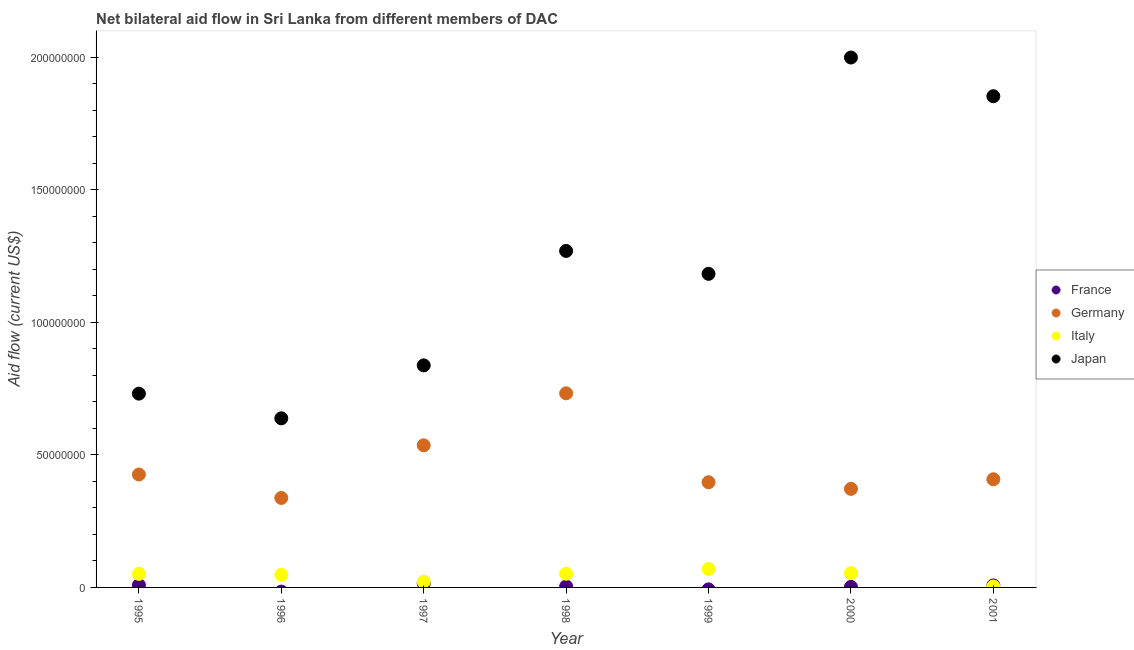Is the number of dotlines equal to the number of legend labels?
Give a very brief answer. No. What is the amount of aid given by germany in 2000?
Your answer should be compact. 3.72e+07. Across all years, what is the maximum amount of aid given by japan?
Offer a terse response. 2.00e+08. Across all years, what is the minimum amount of aid given by italy?
Keep it short and to the point. 3.50e+05. What is the total amount of aid given by japan in the graph?
Your answer should be very brief. 8.51e+08. What is the difference between the amount of aid given by italy in 1995 and that in 2000?
Ensure brevity in your answer.  -3.20e+05. What is the difference between the amount of aid given by italy in 1997 and the amount of aid given by japan in 1998?
Provide a short and direct response. -1.25e+08. What is the average amount of aid given by france per year?
Make the answer very short. 5.44e+05. In the year 2001, what is the difference between the amount of aid given by italy and amount of aid given by japan?
Your answer should be very brief. -1.85e+08. Is the difference between the amount of aid given by france in 1998 and 2001 greater than the difference between the amount of aid given by germany in 1998 and 2001?
Offer a terse response. No. What is the difference between the highest and the second highest amount of aid given by italy?
Your answer should be compact. 1.51e+06. What is the difference between the highest and the lowest amount of aid given by japan?
Give a very brief answer. 1.36e+08. Is the sum of the amount of aid given by germany in 1996 and 2000 greater than the maximum amount of aid given by italy across all years?
Your answer should be compact. Yes. Is it the case that in every year, the sum of the amount of aid given by italy and amount of aid given by japan is greater than the sum of amount of aid given by france and amount of aid given by germany?
Provide a short and direct response. No. How many dotlines are there?
Offer a very short reply. 4. How many years are there in the graph?
Your response must be concise. 7. Does the graph contain any zero values?
Offer a very short reply. Yes. Does the graph contain grids?
Keep it short and to the point. No. How are the legend labels stacked?
Your answer should be compact. Vertical. What is the title of the graph?
Ensure brevity in your answer.  Net bilateral aid flow in Sri Lanka from different members of DAC. What is the label or title of the X-axis?
Your answer should be compact. Year. What is the Aid flow (current US$) of France in 1995?
Keep it short and to the point. 9.00e+05. What is the Aid flow (current US$) in Germany in 1995?
Provide a short and direct response. 4.26e+07. What is the Aid flow (current US$) of Italy in 1995?
Keep it short and to the point. 5.10e+06. What is the Aid flow (current US$) of Japan in 1995?
Provide a short and direct response. 7.31e+07. What is the Aid flow (current US$) of Germany in 1996?
Your answer should be very brief. 3.37e+07. What is the Aid flow (current US$) of Italy in 1996?
Make the answer very short. 4.78e+06. What is the Aid flow (current US$) in Japan in 1996?
Offer a very short reply. 6.38e+07. What is the Aid flow (current US$) in France in 1997?
Offer a terse response. 1.56e+06. What is the Aid flow (current US$) in Germany in 1997?
Make the answer very short. 5.36e+07. What is the Aid flow (current US$) of Italy in 1997?
Keep it short and to the point. 2.17e+06. What is the Aid flow (current US$) of Japan in 1997?
Give a very brief answer. 8.37e+07. What is the Aid flow (current US$) of Germany in 1998?
Your response must be concise. 7.32e+07. What is the Aid flow (current US$) of Italy in 1998?
Your response must be concise. 5.15e+06. What is the Aid flow (current US$) in Japan in 1998?
Offer a terse response. 1.27e+08. What is the Aid flow (current US$) of Germany in 1999?
Keep it short and to the point. 3.97e+07. What is the Aid flow (current US$) of Italy in 1999?
Ensure brevity in your answer.  6.93e+06. What is the Aid flow (current US$) of Japan in 1999?
Keep it short and to the point. 1.18e+08. What is the Aid flow (current US$) in Germany in 2000?
Give a very brief answer. 3.72e+07. What is the Aid flow (current US$) in Italy in 2000?
Keep it short and to the point. 5.42e+06. What is the Aid flow (current US$) in Japan in 2000?
Your answer should be compact. 2.00e+08. What is the Aid flow (current US$) in France in 2001?
Provide a short and direct response. 7.60e+05. What is the Aid flow (current US$) in Germany in 2001?
Ensure brevity in your answer.  4.08e+07. What is the Aid flow (current US$) of Japan in 2001?
Your answer should be very brief. 1.85e+08. Across all years, what is the maximum Aid flow (current US$) in France?
Offer a very short reply. 1.56e+06. Across all years, what is the maximum Aid flow (current US$) in Germany?
Your answer should be compact. 7.32e+07. Across all years, what is the maximum Aid flow (current US$) of Italy?
Your answer should be very brief. 6.93e+06. Across all years, what is the maximum Aid flow (current US$) in Japan?
Offer a very short reply. 2.00e+08. Across all years, what is the minimum Aid flow (current US$) in Germany?
Offer a very short reply. 3.37e+07. Across all years, what is the minimum Aid flow (current US$) of Italy?
Make the answer very short. 3.50e+05. Across all years, what is the minimum Aid flow (current US$) of Japan?
Give a very brief answer. 6.38e+07. What is the total Aid flow (current US$) in France in the graph?
Your answer should be very brief. 3.81e+06. What is the total Aid flow (current US$) in Germany in the graph?
Your response must be concise. 3.21e+08. What is the total Aid flow (current US$) in Italy in the graph?
Offer a very short reply. 2.99e+07. What is the total Aid flow (current US$) in Japan in the graph?
Give a very brief answer. 8.51e+08. What is the difference between the Aid flow (current US$) in Germany in 1995 and that in 1996?
Keep it short and to the point. 8.84e+06. What is the difference between the Aid flow (current US$) in Japan in 1995 and that in 1996?
Ensure brevity in your answer.  9.31e+06. What is the difference between the Aid flow (current US$) in France in 1995 and that in 1997?
Provide a short and direct response. -6.60e+05. What is the difference between the Aid flow (current US$) in Germany in 1995 and that in 1997?
Provide a short and direct response. -1.10e+07. What is the difference between the Aid flow (current US$) of Italy in 1995 and that in 1997?
Your answer should be very brief. 2.93e+06. What is the difference between the Aid flow (current US$) of Japan in 1995 and that in 1997?
Your answer should be very brief. -1.07e+07. What is the difference between the Aid flow (current US$) in France in 1995 and that in 1998?
Make the answer very short. 5.10e+05. What is the difference between the Aid flow (current US$) of Germany in 1995 and that in 1998?
Keep it short and to the point. -3.06e+07. What is the difference between the Aid flow (current US$) in Italy in 1995 and that in 1998?
Offer a very short reply. -5.00e+04. What is the difference between the Aid flow (current US$) of Japan in 1995 and that in 1998?
Your response must be concise. -5.38e+07. What is the difference between the Aid flow (current US$) of Germany in 1995 and that in 1999?
Provide a succinct answer. 2.91e+06. What is the difference between the Aid flow (current US$) of Italy in 1995 and that in 1999?
Your answer should be compact. -1.83e+06. What is the difference between the Aid flow (current US$) of Japan in 1995 and that in 1999?
Offer a very short reply. -4.52e+07. What is the difference between the Aid flow (current US$) in Germany in 1995 and that in 2000?
Your answer should be very brief. 5.41e+06. What is the difference between the Aid flow (current US$) of Italy in 1995 and that in 2000?
Provide a short and direct response. -3.20e+05. What is the difference between the Aid flow (current US$) of Japan in 1995 and that in 2000?
Ensure brevity in your answer.  -1.27e+08. What is the difference between the Aid flow (current US$) in Germany in 1995 and that in 2001?
Keep it short and to the point. 1.79e+06. What is the difference between the Aid flow (current US$) in Italy in 1995 and that in 2001?
Keep it short and to the point. 4.75e+06. What is the difference between the Aid flow (current US$) of Japan in 1995 and that in 2001?
Make the answer very short. -1.12e+08. What is the difference between the Aid flow (current US$) in Germany in 1996 and that in 1997?
Your answer should be compact. -1.98e+07. What is the difference between the Aid flow (current US$) in Italy in 1996 and that in 1997?
Your answer should be very brief. 2.61e+06. What is the difference between the Aid flow (current US$) in Japan in 1996 and that in 1997?
Your answer should be compact. -2.00e+07. What is the difference between the Aid flow (current US$) of Germany in 1996 and that in 1998?
Your answer should be very brief. -3.95e+07. What is the difference between the Aid flow (current US$) in Italy in 1996 and that in 1998?
Keep it short and to the point. -3.70e+05. What is the difference between the Aid flow (current US$) in Japan in 1996 and that in 1998?
Offer a very short reply. -6.31e+07. What is the difference between the Aid flow (current US$) of Germany in 1996 and that in 1999?
Provide a succinct answer. -5.93e+06. What is the difference between the Aid flow (current US$) of Italy in 1996 and that in 1999?
Offer a terse response. -2.15e+06. What is the difference between the Aid flow (current US$) of Japan in 1996 and that in 1999?
Offer a very short reply. -5.45e+07. What is the difference between the Aid flow (current US$) in Germany in 1996 and that in 2000?
Your answer should be compact. -3.43e+06. What is the difference between the Aid flow (current US$) of Italy in 1996 and that in 2000?
Offer a very short reply. -6.40e+05. What is the difference between the Aid flow (current US$) of Japan in 1996 and that in 2000?
Provide a succinct answer. -1.36e+08. What is the difference between the Aid flow (current US$) of Germany in 1996 and that in 2001?
Your answer should be very brief. -7.05e+06. What is the difference between the Aid flow (current US$) of Italy in 1996 and that in 2001?
Keep it short and to the point. 4.43e+06. What is the difference between the Aid flow (current US$) in Japan in 1996 and that in 2001?
Offer a terse response. -1.21e+08. What is the difference between the Aid flow (current US$) of France in 1997 and that in 1998?
Offer a very short reply. 1.17e+06. What is the difference between the Aid flow (current US$) of Germany in 1997 and that in 1998?
Ensure brevity in your answer.  -1.96e+07. What is the difference between the Aid flow (current US$) in Italy in 1997 and that in 1998?
Provide a succinct answer. -2.98e+06. What is the difference between the Aid flow (current US$) in Japan in 1997 and that in 1998?
Your answer should be very brief. -4.32e+07. What is the difference between the Aid flow (current US$) of Germany in 1997 and that in 1999?
Offer a terse response. 1.39e+07. What is the difference between the Aid flow (current US$) in Italy in 1997 and that in 1999?
Your answer should be compact. -4.76e+06. What is the difference between the Aid flow (current US$) of Japan in 1997 and that in 1999?
Give a very brief answer. -3.45e+07. What is the difference between the Aid flow (current US$) of France in 1997 and that in 2000?
Offer a terse response. 1.36e+06. What is the difference between the Aid flow (current US$) of Germany in 1997 and that in 2000?
Your response must be concise. 1.64e+07. What is the difference between the Aid flow (current US$) in Italy in 1997 and that in 2000?
Provide a short and direct response. -3.25e+06. What is the difference between the Aid flow (current US$) of Japan in 1997 and that in 2000?
Your response must be concise. -1.16e+08. What is the difference between the Aid flow (current US$) of France in 1997 and that in 2001?
Provide a succinct answer. 8.00e+05. What is the difference between the Aid flow (current US$) in Germany in 1997 and that in 2001?
Your response must be concise. 1.28e+07. What is the difference between the Aid flow (current US$) of Italy in 1997 and that in 2001?
Keep it short and to the point. 1.82e+06. What is the difference between the Aid flow (current US$) in Japan in 1997 and that in 2001?
Offer a terse response. -1.02e+08. What is the difference between the Aid flow (current US$) in Germany in 1998 and that in 1999?
Provide a short and direct response. 3.35e+07. What is the difference between the Aid flow (current US$) in Italy in 1998 and that in 1999?
Your answer should be compact. -1.78e+06. What is the difference between the Aid flow (current US$) in Japan in 1998 and that in 1999?
Offer a very short reply. 8.65e+06. What is the difference between the Aid flow (current US$) of France in 1998 and that in 2000?
Keep it short and to the point. 1.90e+05. What is the difference between the Aid flow (current US$) of Germany in 1998 and that in 2000?
Ensure brevity in your answer.  3.60e+07. What is the difference between the Aid flow (current US$) of Japan in 1998 and that in 2000?
Your response must be concise. -7.29e+07. What is the difference between the Aid flow (current US$) of France in 1998 and that in 2001?
Offer a very short reply. -3.70e+05. What is the difference between the Aid flow (current US$) of Germany in 1998 and that in 2001?
Your response must be concise. 3.24e+07. What is the difference between the Aid flow (current US$) in Italy in 1998 and that in 2001?
Provide a short and direct response. 4.80e+06. What is the difference between the Aid flow (current US$) in Japan in 1998 and that in 2001?
Your answer should be compact. -5.83e+07. What is the difference between the Aid flow (current US$) in Germany in 1999 and that in 2000?
Your answer should be compact. 2.50e+06. What is the difference between the Aid flow (current US$) in Italy in 1999 and that in 2000?
Your answer should be very brief. 1.51e+06. What is the difference between the Aid flow (current US$) in Japan in 1999 and that in 2000?
Offer a terse response. -8.16e+07. What is the difference between the Aid flow (current US$) of Germany in 1999 and that in 2001?
Your answer should be very brief. -1.12e+06. What is the difference between the Aid flow (current US$) of Italy in 1999 and that in 2001?
Your answer should be very brief. 6.58e+06. What is the difference between the Aid flow (current US$) of Japan in 1999 and that in 2001?
Ensure brevity in your answer.  -6.70e+07. What is the difference between the Aid flow (current US$) in France in 2000 and that in 2001?
Your answer should be very brief. -5.60e+05. What is the difference between the Aid flow (current US$) of Germany in 2000 and that in 2001?
Your answer should be very brief. -3.62e+06. What is the difference between the Aid flow (current US$) in Italy in 2000 and that in 2001?
Keep it short and to the point. 5.07e+06. What is the difference between the Aid flow (current US$) of Japan in 2000 and that in 2001?
Your answer should be very brief. 1.46e+07. What is the difference between the Aid flow (current US$) of France in 1995 and the Aid flow (current US$) of Germany in 1996?
Give a very brief answer. -3.28e+07. What is the difference between the Aid flow (current US$) of France in 1995 and the Aid flow (current US$) of Italy in 1996?
Offer a very short reply. -3.88e+06. What is the difference between the Aid flow (current US$) of France in 1995 and the Aid flow (current US$) of Japan in 1996?
Make the answer very short. -6.29e+07. What is the difference between the Aid flow (current US$) in Germany in 1995 and the Aid flow (current US$) in Italy in 1996?
Provide a succinct answer. 3.78e+07. What is the difference between the Aid flow (current US$) in Germany in 1995 and the Aid flow (current US$) in Japan in 1996?
Offer a terse response. -2.12e+07. What is the difference between the Aid flow (current US$) of Italy in 1995 and the Aid flow (current US$) of Japan in 1996?
Provide a succinct answer. -5.87e+07. What is the difference between the Aid flow (current US$) of France in 1995 and the Aid flow (current US$) of Germany in 1997?
Ensure brevity in your answer.  -5.27e+07. What is the difference between the Aid flow (current US$) in France in 1995 and the Aid flow (current US$) in Italy in 1997?
Keep it short and to the point. -1.27e+06. What is the difference between the Aid flow (current US$) in France in 1995 and the Aid flow (current US$) in Japan in 1997?
Offer a very short reply. -8.28e+07. What is the difference between the Aid flow (current US$) in Germany in 1995 and the Aid flow (current US$) in Italy in 1997?
Ensure brevity in your answer.  4.04e+07. What is the difference between the Aid flow (current US$) of Germany in 1995 and the Aid flow (current US$) of Japan in 1997?
Your answer should be very brief. -4.12e+07. What is the difference between the Aid flow (current US$) of Italy in 1995 and the Aid flow (current US$) of Japan in 1997?
Your answer should be very brief. -7.86e+07. What is the difference between the Aid flow (current US$) in France in 1995 and the Aid flow (current US$) in Germany in 1998?
Give a very brief answer. -7.23e+07. What is the difference between the Aid flow (current US$) of France in 1995 and the Aid flow (current US$) of Italy in 1998?
Offer a terse response. -4.25e+06. What is the difference between the Aid flow (current US$) of France in 1995 and the Aid flow (current US$) of Japan in 1998?
Make the answer very short. -1.26e+08. What is the difference between the Aid flow (current US$) in Germany in 1995 and the Aid flow (current US$) in Italy in 1998?
Ensure brevity in your answer.  3.74e+07. What is the difference between the Aid flow (current US$) in Germany in 1995 and the Aid flow (current US$) in Japan in 1998?
Provide a succinct answer. -8.43e+07. What is the difference between the Aid flow (current US$) in Italy in 1995 and the Aid flow (current US$) in Japan in 1998?
Keep it short and to the point. -1.22e+08. What is the difference between the Aid flow (current US$) in France in 1995 and the Aid flow (current US$) in Germany in 1999?
Make the answer very short. -3.88e+07. What is the difference between the Aid flow (current US$) in France in 1995 and the Aid flow (current US$) in Italy in 1999?
Your answer should be compact. -6.03e+06. What is the difference between the Aid flow (current US$) of France in 1995 and the Aid flow (current US$) of Japan in 1999?
Offer a very short reply. -1.17e+08. What is the difference between the Aid flow (current US$) in Germany in 1995 and the Aid flow (current US$) in Italy in 1999?
Your response must be concise. 3.56e+07. What is the difference between the Aid flow (current US$) in Germany in 1995 and the Aid flow (current US$) in Japan in 1999?
Your answer should be compact. -7.57e+07. What is the difference between the Aid flow (current US$) of Italy in 1995 and the Aid flow (current US$) of Japan in 1999?
Your response must be concise. -1.13e+08. What is the difference between the Aid flow (current US$) in France in 1995 and the Aid flow (current US$) in Germany in 2000?
Ensure brevity in your answer.  -3.63e+07. What is the difference between the Aid flow (current US$) in France in 1995 and the Aid flow (current US$) in Italy in 2000?
Offer a very short reply. -4.52e+06. What is the difference between the Aid flow (current US$) in France in 1995 and the Aid flow (current US$) in Japan in 2000?
Ensure brevity in your answer.  -1.99e+08. What is the difference between the Aid flow (current US$) of Germany in 1995 and the Aid flow (current US$) of Italy in 2000?
Your answer should be compact. 3.72e+07. What is the difference between the Aid flow (current US$) in Germany in 1995 and the Aid flow (current US$) in Japan in 2000?
Keep it short and to the point. -1.57e+08. What is the difference between the Aid flow (current US$) of Italy in 1995 and the Aid flow (current US$) of Japan in 2000?
Make the answer very short. -1.95e+08. What is the difference between the Aid flow (current US$) of France in 1995 and the Aid flow (current US$) of Germany in 2001?
Offer a very short reply. -3.99e+07. What is the difference between the Aid flow (current US$) in France in 1995 and the Aid flow (current US$) in Japan in 2001?
Offer a very short reply. -1.84e+08. What is the difference between the Aid flow (current US$) in Germany in 1995 and the Aid flow (current US$) in Italy in 2001?
Your answer should be very brief. 4.22e+07. What is the difference between the Aid flow (current US$) of Germany in 1995 and the Aid flow (current US$) of Japan in 2001?
Your response must be concise. -1.43e+08. What is the difference between the Aid flow (current US$) of Italy in 1995 and the Aid flow (current US$) of Japan in 2001?
Give a very brief answer. -1.80e+08. What is the difference between the Aid flow (current US$) of Germany in 1996 and the Aid flow (current US$) of Italy in 1997?
Provide a succinct answer. 3.16e+07. What is the difference between the Aid flow (current US$) of Germany in 1996 and the Aid flow (current US$) of Japan in 1997?
Give a very brief answer. -5.00e+07. What is the difference between the Aid flow (current US$) of Italy in 1996 and the Aid flow (current US$) of Japan in 1997?
Provide a succinct answer. -7.90e+07. What is the difference between the Aid flow (current US$) of Germany in 1996 and the Aid flow (current US$) of Italy in 1998?
Provide a short and direct response. 2.86e+07. What is the difference between the Aid flow (current US$) in Germany in 1996 and the Aid flow (current US$) in Japan in 1998?
Provide a succinct answer. -9.32e+07. What is the difference between the Aid flow (current US$) in Italy in 1996 and the Aid flow (current US$) in Japan in 1998?
Offer a very short reply. -1.22e+08. What is the difference between the Aid flow (current US$) of Germany in 1996 and the Aid flow (current US$) of Italy in 1999?
Your answer should be compact. 2.68e+07. What is the difference between the Aid flow (current US$) in Germany in 1996 and the Aid flow (current US$) in Japan in 1999?
Your answer should be compact. -8.45e+07. What is the difference between the Aid flow (current US$) of Italy in 1996 and the Aid flow (current US$) of Japan in 1999?
Ensure brevity in your answer.  -1.13e+08. What is the difference between the Aid flow (current US$) in Germany in 1996 and the Aid flow (current US$) in Italy in 2000?
Keep it short and to the point. 2.83e+07. What is the difference between the Aid flow (current US$) in Germany in 1996 and the Aid flow (current US$) in Japan in 2000?
Offer a very short reply. -1.66e+08. What is the difference between the Aid flow (current US$) in Italy in 1996 and the Aid flow (current US$) in Japan in 2000?
Provide a succinct answer. -1.95e+08. What is the difference between the Aid flow (current US$) of Germany in 1996 and the Aid flow (current US$) of Italy in 2001?
Give a very brief answer. 3.34e+07. What is the difference between the Aid flow (current US$) of Germany in 1996 and the Aid flow (current US$) of Japan in 2001?
Offer a very short reply. -1.52e+08. What is the difference between the Aid flow (current US$) of Italy in 1996 and the Aid flow (current US$) of Japan in 2001?
Your answer should be compact. -1.80e+08. What is the difference between the Aid flow (current US$) in France in 1997 and the Aid flow (current US$) in Germany in 1998?
Ensure brevity in your answer.  -7.16e+07. What is the difference between the Aid flow (current US$) in France in 1997 and the Aid flow (current US$) in Italy in 1998?
Your answer should be compact. -3.59e+06. What is the difference between the Aid flow (current US$) of France in 1997 and the Aid flow (current US$) of Japan in 1998?
Make the answer very short. -1.25e+08. What is the difference between the Aid flow (current US$) of Germany in 1997 and the Aid flow (current US$) of Italy in 1998?
Your response must be concise. 4.84e+07. What is the difference between the Aid flow (current US$) of Germany in 1997 and the Aid flow (current US$) of Japan in 1998?
Your response must be concise. -7.33e+07. What is the difference between the Aid flow (current US$) of Italy in 1997 and the Aid flow (current US$) of Japan in 1998?
Ensure brevity in your answer.  -1.25e+08. What is the difference between the Aid flow (current US$) of France in 1997 and the Aid flow (current US$) of Germany in 1999?
Give a very brief answer. -3.81e+07. What is the difference between the Aid flow (current US$) of France in 1997 and the Aid flow (current US$) of Italy in 1999?
Give a very brief answer. -5.37e+06. What is the difference between the Aid flow (current US$) of France in 1997 and the Aid flow (current US$) of Japan in 1999?
Provide a short and direct response. -1.17e+08. What is the difference between the Aid flow (current US$) of Germany in 1997 and the Aid flow (current US$) of Italy in 1999?
Give a very brief answer. 4.67e+07. What is the difference between the Aid flow (current US$) of Germany in 1997 and the Aid flow (current US$) of Japan in 1999?
Make the answer very short. -6.47e+07. What is the difference between the Aid flow (current US$) in Italy in 1997 and the Aid flow (current US$) in Japan in 1999?
Offer a terse response. -1.16e+08. What is the difference between the Aid flow (current US$) in France in 1997 and the Aid flow (current US$) in Germany in 2000?
Keep it short and to the point. -3.56e+07. What is the difference between the Aid flow (current US$) of France in 1997 and the Aid flow (current US$) of Italy in 2000?
Keep it short and to the point. -3.86e+06. What is the difference between the Aid flow (current US$) in France in 1997 and the Aid flow (current US$) in Japan in 2000?
Make the answer very short. -1.98e+08. What is the difference between the Aid flow (current US$) in Germany in 1997 and the Aid flow (current US$) in Italy in 2000?
Your response must be concise. 4.82e+07. What is the difference between the Aid flow (current US$) in Germany in 1997 and the Aid flow (current US$) in Japan in 2000?
Give a very brief answer. -1.46e+08. What is the difference between the Aid flow (current US$) of Italy in 1997 and the Aid flow (current US$) of Japan in 2000?
Make the answer very short. -1.98e+08. What is the difference between the Aid flow (current US$) in France in 1997 and the Aid flow (current US$) in Germany in 2001?
Provide a short and direct response. -3.92e+07. What is the difference between the Aid flow (current US$) of France in 1997 and the Aid flow (current US$) of Italy in 2001?
Your response must be concise. 1.21e+06. What is the difference between the Aid flow (current US$) in France in 1997 and the Aid flow (current US$) in Japan in 2001?
Provide a succinct answer. -1.84e+08. What is the difference between the Aid flow (current US$) of Germany in 1997 and the Aid flow (current US$) of Italy in 2001?
Provide a succinct answer. 5.32e+07. What is the difference between the Aid flow (current US$) of Germany in 1997 and the Aid flow (current US$) of Japan in 2001?
Offer a very short reply. -1.32e+08. What is the difference between the Aid flow (current US$) in Italy in 1997 and the Aid flow (current US$) in Japan in 2001?
Give a very brief answer. -1.83e+08. What is the difference between the Aid flow (current US$) of France in 1998 and the Aid flow (current US$) of Germany in 1999?
Your response must be concise. -3.93e+07. What is the difference between the Aid flow (current US$) in France in 1998 and the Aid flow (current US$) in Italy in 1999?
Offer a very short reply. -6.54e+06. What is the difference between the Aid flow (current US$) of France in 1998 and the Aid flow (current US$) of Japan in 1999?
Your answer should be very brief. -1.18e+08. What is the difference between the Aid flow (current US$) in Germany in 1998 and the Aid flow (current US$) in Italy in 1999?
Offer a very short reply. 6.63e+07. What is the difference between the Aid flow (current US$) of Germany in 1998 and the Aid flow (current US$) of Japan in 1999?
Ensure brevity in your answer.  -4.50e+07. What is the difference between the Aid flow (current US$) in Italy in 1998 and the Aid flow (current US$) in Japan in 1999?
Give a very brief answer. -1.13e+08. What is the difference between the Aid flow (current US$) of France in 1998 and the Aid flow (current US$) of Germany in 2000?
Keep it short and to the point. -3.68e+07. What is the difference between the Aid flow (current US$) of France in 1998 and the Aid flow (current US$) of Italy in 2000?
Ensure brevity in your answer.  -5.03e+06. What is the difference between the Aid flow (current US$) in France in 1998 and the Aid flow (current US$) in Japan in 2000?
Your response must be concise. -1.99e+08. What is the difference between the Aid flow (current US$) of Germany in 1998 and the Aid flow (current US$) of Italy in 2000?
Offer a very short reply. 6.78e+07. What is the difference between the Aid flow (current US$) in Germany in 1998 and the Aid flow (current US$) in Japan in 2000?
Your answer should be compact. -1.27e+08. What is the difference between the Aid flow (current US$) in Italy in 1998 and the Aid flow (current US$) in Japan in 2000?
Your response must be concise. -1.95e+08. What is the difference between the Aid flow (current US$) of France in 1998 and the Aid flow (current US$) of Germany in 2001?
Provide a succinct answer. -4.04e+07. What is the difference between the Aid flow (current US$) of France in 1998 and the Aid flow (current US$) of Japan in 2001?
Offer a terse response. -1.85e+08. What is the difference between the Aid flow (current US$) in Germany in 1998 and the Aid flow (current US$) in Italy in 2001?
Keep it short and to the point. 7.28e+07. What is the difference between the Aid flow (current US$) of Germany in 1998 and the Aid flow (current US$) of Japan in 2001?
Make the answer very short. -1.12e+08. What is the difference between the Aid flow (current US$) of Italy in 1998 and the Aid flow (current US$) of Japan in 2001?
Give a very brief answer. -1.80e+08. What is the difference between the Aid flow (current US$) of Germany in 1999 and the Aid flow (current US$) of Italy in 2000?
Your response must be concise. 3.42e+07. What is the difference between the Aid flow (current US$) in Germany in 1999 and the Aid flow (current US$) in Japan in 2000?
Offer a terse response. -1.60e+08. What is the difference between the Aid flow (current US$) in Italy in 1999 and the Aid flow (current US$) in Japan in 2000?
Provide a succinct answer. -1.93e+08. What is the difference between the Aid flow (current US$) in Germany in 1999 and the Aid flow (current US$) in Italy in 2001?
Provide a short and direct response. 3.93e+07. What is the difference between the Aid flow (current US$) of Germany in 1999 and the Aid flow (current US$) of Japan in 2001?
Your response must be concise. -1.46e+08. What is the difference between the Aid flow (current US$) of Italy in 1999 and the Aid flow (current US$) of Japan in 2001?
Ensure brevity in your answer.  -1.78e+08. What is the difference between the Aid flow (current US$) of France in 2000 and the Aid flow (current US$) of Germany in 2001?
Provide a short and direct response. -4.06e+07. What is the difference between the Aid flow (current US$) in France in 2000 and the Aid flow (current US$) in Japan in 2001?
Your answer should be very brief. -1.85e+08. What is the difference between the Aid flow (current US$) in Germany in 2000 and the Aid flow (current US$) in Italy in 2001?
Keep it short and to the point. 3.68e+07. What is the difference between the Aid flow (current US$) in Germany in 2000 and the Aid flow (current US$) in Japan in 2001?
Make the answer very short. -1.48e+08. What is the difference between the Aid flow (current US$) in Italy in 2000 and the Aid flow (current US$) in Japan in 2001?
Give a very brief answer. -1.80e+08. What is the average Aid flow (current US$) in France per year?
Offer a terse response. 5.44e+05. What is the average Aid flow (current US$) of Germany per year?
Offer a terse response. 4.58e+07. What is the average Aid flow (current US$) in Italy per year?
Give a very brief answer. 4.27e+06. What is the average Aid flow (current US$) in Japan per year?
Provide a short and direct response. 1.22e+08. In the year 1995, what is the difference between the Aid flow (current US$) of France and Aid flow (current US$) of Germany?
Your answer should be compact. -4.17e+07. In the year 1995, what is the difference between the Aid flow (current US$) of France and Aid flow (current US$) of Italy?
Provide a succinct answer. -4.20e+06. In the year 1995, what is the difference between the Aid flow (current US$) of France and Aid flow (current US$) of Japan?
Provide a succinct answer. -7.22e+07. In the year 1995, what is the difference between the Aid flow (current US$) in Germany and Aid flow (current US$) in Italy?
Give a very brief answer. 3.75e+07. In the year 1995, what is the difference between the Aid flow (current US$) of Germany and Aid flow (current US$) of Japan?
Your response must be concise. -3.05e+07. In the year 1995, what is the difference between the Aid flow (current US$) in Italy and Aid flow (current US$) in Japan?
Provide a short and direct response. -6.80e+07. In the year 1996, what is the difference between the Aid flow (current US$) of Germany and Aid flow (current US$) of Italy?
Ensure brevity in your answer.  2.90e+07. In the year 1996, what is the difference between the Aid flow (current US$) in Germany and Aid flow (current US$) in Japan?
Offer a very short reply. -3.00e+07. In the year 1996, what is the difference between the Aid flow (current US$) of Italy and Aid flow (current US$) of Japan?
Offer a very short reply. -5.90e+07. In the year 1997, what is the difference between the Aid flow (current US$) of France and Aid flow (current US$) of Germany?
Make the answer very short. -5.20e+07. In the year 1997, what is the difference between the Aid flow (current US$) of France and Aid flow (current US$) of Italy?
Provide a short and direct response. -6.10e+05. In the year 1997, what is the difference between the Aid flow (current US$) of France and Aid flow (current US$) of Japan?
Your answer should be very brief. -8.22e+07. In the year 1997, what is the difference between the Aid flow (current US$) in Germany and Aid flow (current US$) in Italy?
Provide a short and direct response. 5.14e+07. In the year 1997, what is the difference between the Aid flow (current US$) of Germany and Aid flow (current US$) of Japan?
Provide a short and direct response. -3.02e+07. In the year 1997, what is the difference between the Aid flow (current US$) in Italy and Aid flow (current US$) in Japan?
Keep it short and to the point. -8.16e+07. In the year 1998, what is the difference between the Aid flow (current US$) of France and Aid flow (current US$) of Germany?
Your response must be concise. -7.28e+07. In the year 1998, what is the difference between the Aid flow (current US$) of France and Aid flow (current US$) of Italy?
Your answer should be compact. -4.76e+06. In the year 1998, what is the difference between the Aid flow (current US$) in France and Aid flow (current US$) in Japan?
Your answer should be very brief. -1.27e+08. In the year 1998, what is the difference between the Aid flow (current US$) in Germany and Aid flow (current US$) in Italy?
Give a very brief answer. 6.80e+07. In the year 1998, what is the difference between the Aid flow (current US$) in Germany and Aid flow (current US$) in Japan?
Offer a very short reply. -5.37e+07. In the year 1998, what is the difference between the Aid flow (current US$) in Italy and Aid flow (current US$) in Japan?
Make the answer very short. -1.22e+08. In the year 1999, what is the difference between the Aid flow (current US$) of Germany and Aid flow (current US$) of Italy?
Your response must be concise. 3.27e+07. In the year 1999, what is the difference between the Aid flow (current US$) of Germany and Aid flow (current US$) of Japan?
Offer a terse response. -7.86e+07. In the year 1999, what is the difference between the Aid flow (current US$) of Italy and Aid flow (current US$) of Japan?
Your answer should be very brief. -1.11e+08. In the year 2000, what is the difference between the Aid flow (current US$) of France and Aid flow (current US$) of Germany?
Your response must be concise. -3.70e+07. In the year 2000, what is the difference between the Aid flow (current US$) in France and Aid flow (current US$) in Italy?
Offer a terse response. -5.22e+06. In the year 2000, what is the difference between the Aid flow (current US$) in France and Aid flow (current US$) in Japan?
Your answer should be compact. -2.00e+08. In the year 2000, what is the difference between the Aid flow (current US$) in Germany and Aid flow (current US$) in Italy?
Provide a succinct answer. 3.18e+07. In the year 2000, what is the difference between the Aid flow (current US$) in Germany and Aid flow (current US$) in Japan?
Your response must be concise. -1.63e+08. In the year 2000, what is the difference between the Aid flow (current US$) of Italy and Aid flow (current US$) of Japan?
Your answer should be compact. -1.94e+08. In the year 2001, what is the difference between the Aid flow (current US$) of France and Aid flow (current US$) of Germany?
Offer a very short reply. -4.00e+07. In the year 2001, what is the difference between the Aid flow (current US$) of France and Aid flow (current US$) of Japan?
Keep it short and to the point. -1.84e+08. In the year 2001, what is the difference between the Aid flow (current US$) in Germany and Aid flow (current US$) in Italy?
Make the answer very short. 4.04e+07. In the year 2001, what is the difference between the Aid flow (current US$) of Germany and Aid flow (current US$) of Japan?
Provide a short and direct response. -1.44e+08. In the year 2001, what is the difference between the Aid flow (current US$) of Italy and Aid flow (current US$) of Japan?
Make the answer very short. -1.85e+08. What is the ratio of the Aid flow (current US$) of Germany in 1995 to that in 1996?
Provide a short and direct response. 1.26. What is the ratio of the Aid flow (current US$) of Italy in 1995 to that in 1996?
Ensure brevity in your answer.  1.07. What is the ratio of the Aid flow (current US$) of Japan in 1995 to that in 1996?
Provide a succinct answer. 1.15. What is the ratio of the Aid flow (current US$) in France in 1995 to that in 1997?
Provide a succinct answer. 0.58. What is the ratio of the Aid flow (current US$) of Germany in 1995 to that in 1997?
Your answer should be compact. 0.79. What is the ratio of the Aid flow (current US$) in Italy in 1995 to that in 1997?
Offer a very short reply. 2.35. What is the ratio of the Aid flow (current US$) in Japan in 1995 to that in 1997?
Offer a very short reply. 0.87. What is the ratio of the Aid flow (current US$) of France in 1995 to that in 1998?
Keep it short and to the point. 2.31. What is the ratio of the Aid flow (current US$) of Germany in 1995 to that in 1998?
Make the answer very short. 0.58. What is the ratio of the Aid flow (current US$) of Italy in 1995 to that in 1998?
Your answer should be compact. 0.99. What is the ratio of the Aid flow (current US$) of Japan in 1995 to that in 1998?
Provide a succinct answer. 0.58. What is the ratio of the Aid flow (current US$) of Germany in 1995 to that in 1999?
Offer a very short reply. 1.07. What is the ratio of the Aid flow (current US$) in Italy in 1995 to that in 1999?
Your answer should be compact. 0.74. What is the ratio of the Aid flow (current US$) of Japan in 1995 to that in 1999?
Keep it short and to the point. 0.62. What is the ratio of the Aid flow (current US$) in Germany in 1995 to that in 2000?
Provide a succinct answer. 1.15. What is the ratio of the Aid flow (current US$) in Italy in 1995 to that in 2000?
Your response must be concise. 0.94. What is the ratio of the Aid flow (current US$) of Japan in 1995 to that in 2000?
Ensure brevity in your answer.  0.37. What is the ratio of the Aid flow (current US$) in France in 1995 to that in 2001?
Keep it short and to the point. 1.18. What is the ratio of the Aid flow (current US$) in Germany in 1995 to that in 2001?
Your answer should be compact. 1.04. What is the ratio of the Aid flow (current US$) in Italy in 1995 to that in 2001?
Provide a succinct answer. 14.57. What is the ratio of the Aid flow (current US$) in Japan in 1995 to that in 2001?
Make the answer very short. 0.39. What is the ratio of the Aid flow (current US$) in Germany in 1996 to that in 1997?
Give a very brief answer. 0.63. What is the ratio of the Aid flow (current US$) of Italy in 1996 to that in 1997?
Your response must be concise. 2.2. What is the ratio of the Aid flow (current US$) in Japan in 1996 to that in 1997?
Your answer should be compact. 0.76. What is the ratio of the Aid flow (current US$) of Germany in 1996 to that in 1998?
Ensure brevity in your answer.  0.46. What is the ratio of the Aid flow (current US$) of Italy in 1996 to that in 1998?
Ensure brevity in your answer.  0.93. What is the ratio of the Aid flow (current US$) in Japan in 1996 to that in 1998?
Make the answer very short. 0.5. What is the ratio of the Aid flow (current US$) in Germany in 1996 to that in 1999?
Keep it short and to the point. 0.85. What is the ratio of the Aid flow (current US$) in Italy in 1996 to that in 1999?
Your response must be concise. 0.69. What is the ratio of the Aid flow (current US$) of Japan in 1996 to that in 1999?
Offer a terse response. 0.54. What is the ratio of the Aid flow (current US$) of Germany in 1996 to that in 2000?
Ensure brevity in your answer.  0.91. What is the ratio of the Aid flow (current US$) in Italy in 1996 to that in 2000?
Offer a terse response. 0.88. What is the ratio of the Aid flow (current US$) of Japan in 1996 to that in 2000?
Provide a short and direct response. 0.32. What is the ratio of the Aid flow (current US$) in Germany in 1996 to that in 2001?
Give a very brief answer. 0.83. What is the ratio of the Aid flow (current US$) of Italy in 1996 to that in 2001?
Your answer should be very brief. 13.66. What is the ratio of the Aid flow (current US$) in Japan in 1996 to that in 2001?
Give a very brief answer. 0.34. What is the ratio of the Aid flow (current US$) in France in 1997 to that in 1998?
Your answer should be compact. 4. What is the ratio of the Aid flow (current US$) in Germany in 1997 to that in 1998?
Your answer should be very brief. 0.73. What is the ratio of the Aid flow (current US$) of Italy in 1997 to that in 1998?
Offer a very short reply. 0.42. What is the ratio of the Aid flow (current US$) in Japan in 1997 to that in 1998?
Offer a very short reply. 0.66. What is the ratio of the Aid flow (current US$) of Germany in 1997 to that in 1999?
Your response must be concise. 1.35. What is the ratio of the Aid flow (current US$) of Italy in 1997 to that in 1999?
Offer a terse response. 0.31. What is the ratio of the Aid flow (current US$) of Japan in 1997 to that in 1999?
Provide a succinct answer. 0.71. What is the ratio of the Aid flow (current US$) in France in 1997 to that in 2000?
Your response must be concise. 7.8. What is the ratio of the Aid flow (current US$) of Germany in 1997 to that in 2000?
Provide a succinct answer. 1.44. What is the ratio of the Aid flow (current US$) of Italy in 1997 to that in 2000?
Your answer should be compact. 0.4. What is the ratio of the Aid flow (current US$) of Japan in 1997 to that in 2000?
Make the answer very short. 0.42. What is the ratio of the Aid flow (current US$) of France in 1997 to that in 2001?
Keep it short and to the point. 2.05. What is the ratio of the Aid flow (current US$) of Germany in 1997 to that in 2001?
Ensure brevity in your answer.  1.31. What is the ratio of the Aid flow (current US$) of Italy in 1997 to that in 2001?
Provide a succinct answer. 6.2. What is the ratio of the Aid flow (current US$) of Japan in 1997 to that in 2001?
Provide a short and direct response. 0.45. What is the ratio of the Aid flow (current US$) of Germany in 1998 to that in 1999?
Ensure brevity in your answer.  1.85. What is the ratio of the Aid flow (current US$) of Italy in 1998 to that in 1999?
Ensure brevity in your answer.  0.74. What is the ratio of the Aid flow (current US$) of Japan in 1998 to that in 1999?
Offer a terse response. 1.07. What is the ratio of the Aid flow (current US$) in France in 1998 to that in 2000?
Your answer should be compact. 1.95. What is the ratio of the Aid flow (current US$) of Germany in 1998 to that in 2000?
Give a very brief answer. 1.97. What is the ratio of the Aid flow (current US$) in Italy in 1998 to that in 2000?
Provide a short and direct response. 0.95. What is the ratio of the Aid flow (current US$) of Japan in 1998 to that in 2000?
Your answer should be compact. 0.64. What is the ratio of the Aid flow (current US$) of France in 1998 to that in 2001?
Provide a succinct answer. 0.51. What is the ratio of the Aid flow (current US$) in Germany in 1998 to that in 2001?
Ensure brevity in your answer.  1.79. What is the ratio of the Aid flow (current US$) of Italy in 1998 to that in 2001?
Give a very brief answer. 14.71. What is the ratio of the Aid flow (current US$) of Japan in 1998 to that in 2001?
Offer a very short reply. 0.69. What is the ratio of the Aid flow (current US$) in Germany in 1999 to that in 2000?
Ensure brevity in your answer.  1.07. What is the ratio of the Aid flow (current US$) of Italy in 1999 to that in 2000?
Make the answer very short. 1.28. What is the ratio of the Aid flow (current US$) of Japan in 1999 to that in 2000?
Your answer should be compact. 0.59. What is the ratio of the Aid flow (current US$) of Germany in 1999 to that in 2001?
Your answer should be very brief. 0.97. What is the ratio of the Aid flow (current US$) of Italy in 1999 to that in 2001?
Provide a short and direct response. 19.8. What is the ratio of the Aid flow (current US$) of Japan in 1999 to that in 2001?
Ensure brevity in your answer.  0.64. What is the ratio of the Aid flow (current US$) of France in 2000 to that in 2001?
Your answer should be very brief. 0.26. What is the ratio of the Aid flow (current US$) of Germany in 2000 to that in 2001?
Keep it short and to the point. 0.91. What is the ratio of the Aid flow (current US$) of Italy in 2000 to that in 2001?
Your response must be concise. 15.49. What is the ratio of the Aid flow (current US$) of Japan in 2000 to that in 2001?
Provide a succinct answer. 1.08. What is the difference between the highest and the second highest Aid flow (current US$) of Germany?
Make the answer very short. 1.96e+07. What is the difference between the highest and the second highest Aid flow (current US$) in Italy?
Keep it short and to the point. 1.51e+06. What is the difference between the highest and the second highest Aid flow (current US$) in Japan?
Offer a very short reply. 1.46e+07. What is the difference between the highest and the lowest Aid flow (current US$) of France?
Provide a succinct answer. 1.56e+06. What is the difference between the highest and the lowest Aid flow (current US$) of Germany?
Give a very brief answer. 3.95e+07. What is the difference between the highest and the lowest Aid flow (current US$) in Italy?
Your answer should be very brief. 6.58e+06. What is the difference between the highest and the lowest Aid flow (current US$) in Japan?
Offer a very short reply. 1.36e+08. 